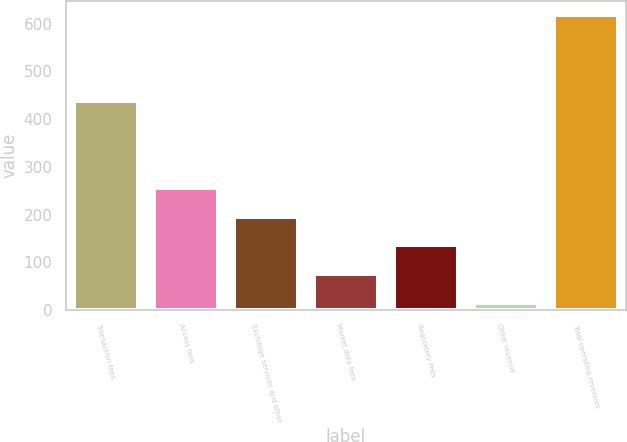Convert chart to OTSL. <chart><loc_0><loc_0><loc_500><loc_500><bar_chart><fcel>Transaction fees<fcel>Access fees<fcel>Exchange services and other<fcel>Market data fees<fcel>Regulatory fees<fcel>Other revenue<fcel>Total operating revenues<nl><fcel>437.8<fcel>255.64<fcel>195.38<fcel>74.86<fcel>135.12<fcel>14.6<fcel>617.2<nl></chart> 